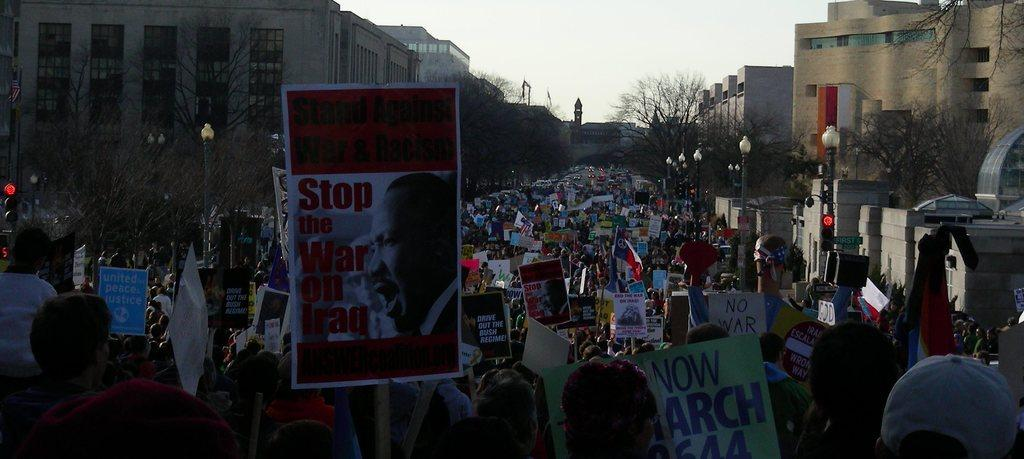What are the people in the image doing? The people in the image are protesting. What are the protesters holding in their hands? The people are holding posters. Where is the protest taking place? The protest is taking place on a road. What can be seen in the background of the image? There are buildings, trees, light poles, and the sky visible in the background of the image. What type of clouds can be seen in the image? There are no clouds mentioned or visible in the image. 